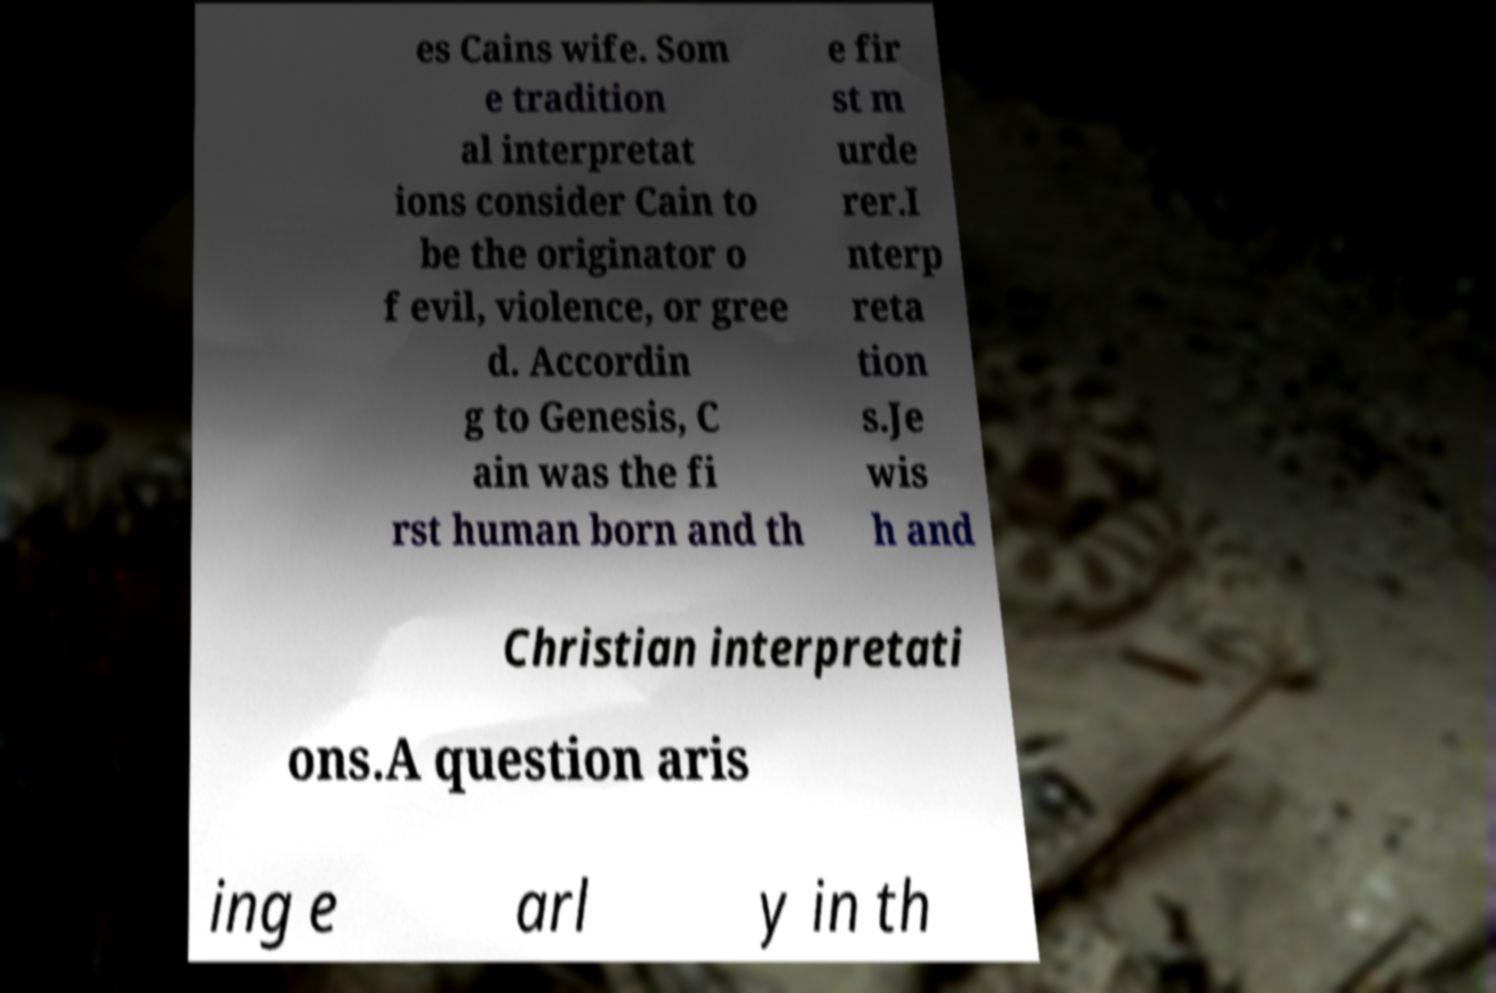Please identify and transcribe the text found in this image. es Cains wife. Som e tradition al interpretat ions consider Cain to be the originator o f evil, violence, or gree d. Accordin g to Genesis, C ain was the fi rst human born and th e fir st m urde rer.I nterp reta tion s.Je wis h and Christian interpretati ons.A question aris ing e arl y in th 